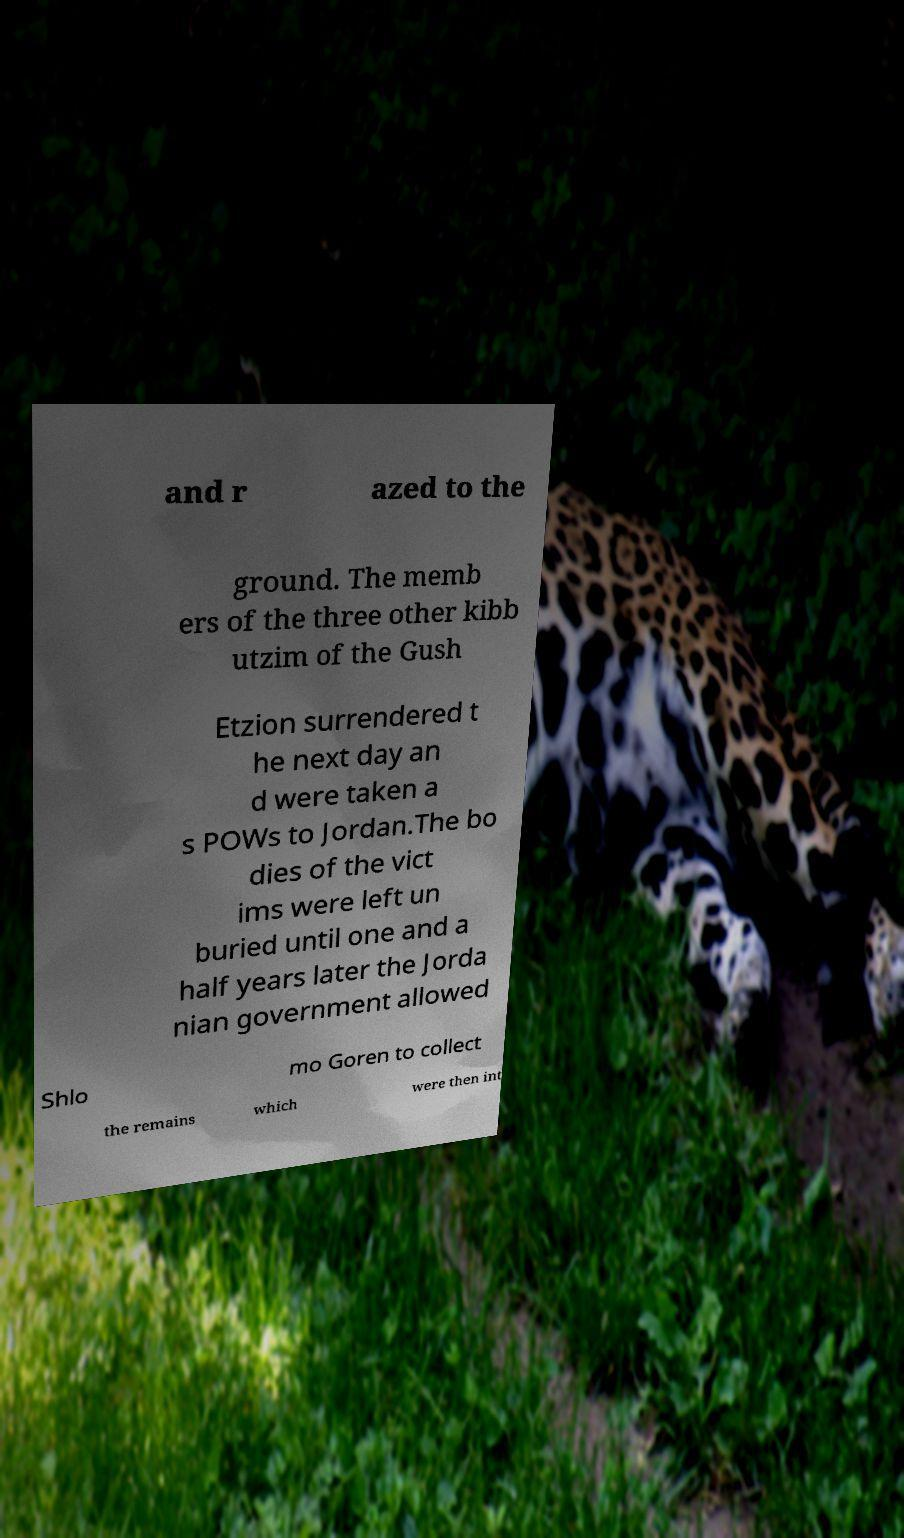Please read and relay the text visible in this image. What does it say? and r azed to the ground. The memb ers of the three other kibb utzim of the Gush Etzion surrendered t he next day an d were taken a s POWs to Jordan.The bo dies of the vict ims were left un buried until one and a half years later the Jorda nian government allowed Shlo mo Goren to collect the remains which were then int 